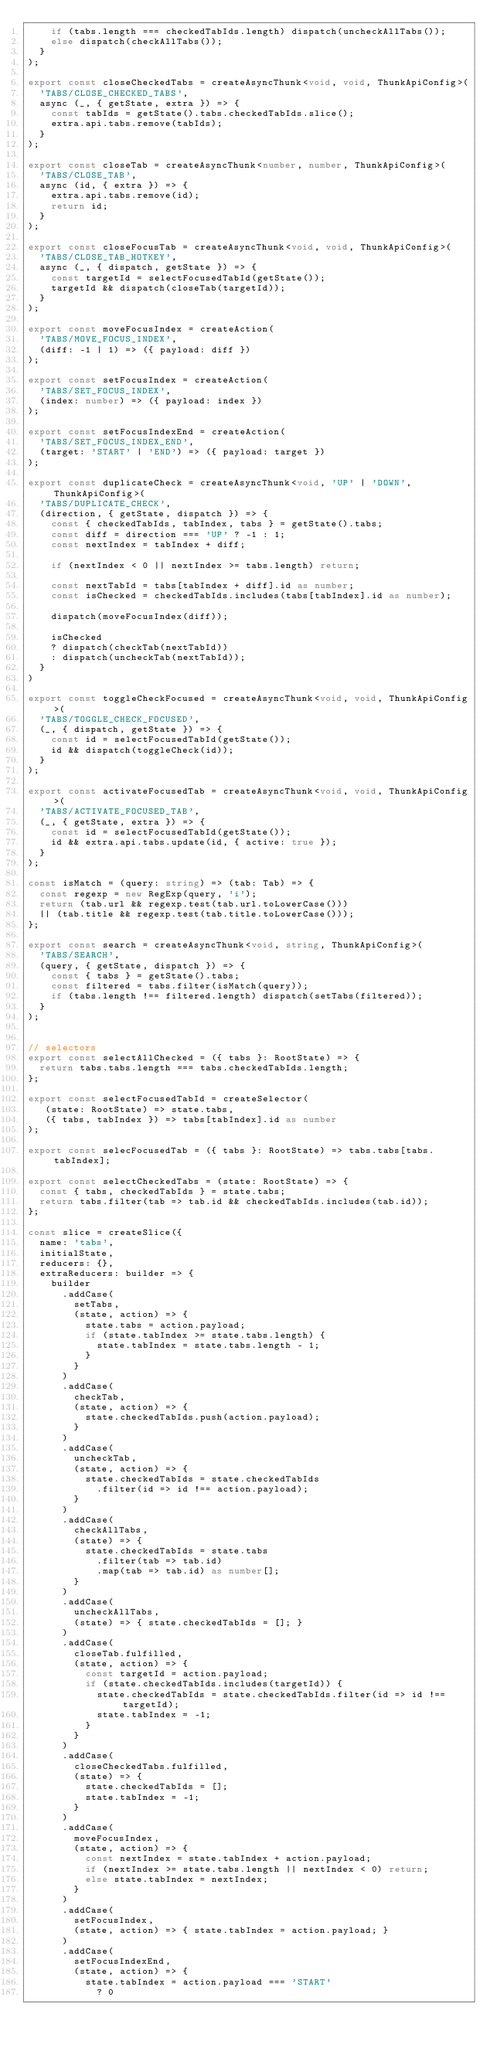Convert code to text. <code><loc_0><loc_0><loc_500><loc_500><_TypeScript_>    if (tabs.length === checkedTabIds.length) dispatch(uncheckAllTabs());
    else dispatch(checkAllTabs());
  }
);

export const closeCheckedTabs = createAsyncThunk<void, void, ThunkApiConfig>(
  'TABS/CLOSE_CHECKED_TABS',
  async (_, { getState, extra }) => {
    const tabIds = getState().tabs.checkedTabIds.slice();
    extra.api.tabs.remove(tabIds);
  }
);

export const closeTab = createAsyncThunk<number, number, ThunkApiConfig>(
  'TABS/CLOSE_TAB',
  async (id, { extra }) => {
    extra.api.tabs.remove(id);
    return id;
  }
);

export const closeFocusTab = createAsyncThunk<void, void, ThunkApiConfig>(
  'TABS/CLOSE_TAB_HOTKEY',
  async (_, { dispatch, getState }) => {
    const targetId = selectFocusedTabId(getState());
    targetId && dispatch(closeTab(targetId));
  }
);

export const moveFocusIndex = createAction(
  'TABS/MOVE_FOCUS_INDEX',
  (diff: -1 | 1) => ({ payload: diff })
);

export const setFocusIndex = createAction(
  'TABS/SET_FOCUS_INDEX',
  (index: number) => ({ payload: index })
);

export const setFocusIndexEnd = createAction(
  'TABS/SET_FOCUS_INDEX_END',
  (target: 'START' | 'END') => ({ payload: target })
);

export const duplicateCheck = createAsyncThunk<void, 'UP' | 'DOWN', ThunkApiConfig>(
  'TABS/DUPLICATE_CHECK',
  (direction, { getState, dispatch }) => {
    const { checkedTabIds, tabIndex, tabs } = getState().tabs;
    const diff = direction === 'UP' ? -1 : 1;
    const nextIndex = tabIndex + diff;
    
    if (nextIndex < 0 || nextIndex >= tabs.length) return;
    
    const nextTabId = tabs[tabIndex + diff].id as number;
    const isChecked = checkedTabIds.includes(tabs[tabIndex].id as number);
    
    dispatch(moveFocusIndex(diff));

    isChecked
    ? dispatch(checkTab(nextTabId))
    : dispatch(uncheckTab(nextTabId));
  }
)

export const toggleCheckFocused = createAsyncThunk<void, void, ThunkApiConfig>(
  'TABS/TOGGLE_CHECK_FOCUSED',
  (_, { dispatch, getState }) => {
    const id = selectFocusedTabId(getState());
    id && dispatch(toggleCheck(id));
  }
);

export const activateFocusedTab = createAsyncThunk<void, void, ThunkApiConfig>(
  'TABS/ACTIVATE_FOCUSED_TAB',
  (_, { getState, extra }) => {
    const id = selectFocusedTabId(getState());
    id && extra.api.tabs.update(id, { active: true });
  }
);

const isMatch = (query: string) => (tab: Tab) => {
  const regexp = new RegExp(query, 'i');
  return (tab.url && regexp.test(tab.url.toLowerCase()))
  || (tab.title && regexp.test(tab.title.toLowerCase()));
};

export const search = createAsyncThunk<void, string, ThunkApiConfig>(
  'TABS/SEARCH',
  (query, { getState, dispatch }) => {
    const { tabs } = getState().tabs;
    const filtered = tabs.filter(isMatch(query));
    if (tabs.length !== filtered.length) dispatch(setTabs(filtered));
  }
);


// selectors
export const selectAllChecked = ({ tabs }: RootState) => {
  return tabs.tabs.length === tabs.checkedTabIds.length;
};

export const selectFocusedTabId = createSelector(
   (state: RootState) => state.tabs,
   ({ tabs, tabIndex }) => tabs[tabIndex].id as number
);

export const selecFocusedTab = ({ tabs }: RootState) => tabs.tabs[tabs.tabIndex];

export const selectCheckedTabs = (state: RootState) => {
  const { tabs, checkedTabIds } = state.tabs;
  return tabs.filter(tab => tab.id && checkedTabIds.includes(tab.id));
};

const slice = createSlice({
  name: 'tabs',
  initialState,
  reducers: {},
  extraReducers: builder => {
    builder
      .addCase(
        setTabs,
        (state, action) => {
          state.tabs = action.payload;
          if (state.tabIndex >= state.tabs.length) {
            state.tabIndex = state.tabs.length - 1;
          }
        }
      )
      .addCase(
        checkTab,
        (state, action) => {
          state.checkedTabIds.push(action.payload);
        }
      )
      .addCase(
        uncheckTab,
        (state, action) => {
          state.checkedTabIds = state.checkedTabIds
            .filter(id => id !== action.payload);
        }
      )
      .addCase(
        checkAllTabs,
        (state) => {
          state.checkedTabIds = state.tabs
            .filter(tab => tab.id)
            .map(tab => tab.id) as number[];
        }
      )
      .addCase(
        uncheckAllTabs,
        (state) => { state.checkedTabIds = []; }
      )
      .addCase(
        closeTab.fulfilled,
        (state, action) => {
          const targetId = action.payload;
          if (state.checkedTabIds.includes(targetId)) {
            state.checkedTabIds = state.checkedTabIds.filter(id => id !== targetId);
            state.tabIndex = -1;
          }
        }
      )
      .addCase(
        closeCheckedTabs.fulfilled,
        (state) => {
          state.checkedTabIds = [];
          state.tabIndex = -1;
        }
      )
      .addCase(
        moveFocusIndex,
        (state, action) => {
          const nextIndex = state.tabIndex + action.payload;
          if (nextIndex >= state.tabs.length || nextIndex < 0) return;
          else state.tabIndex = nextIndex;
        }
      )
      .addCase(
        setFocusIndex,
        (state, action) => { state.tabIndex = action.payload; }
      )
      .addCase(
        setFocusIndexEnd,
        (state, action) => {
          state.tabIndex = action.payload === 'START'
            ? 0</code> 